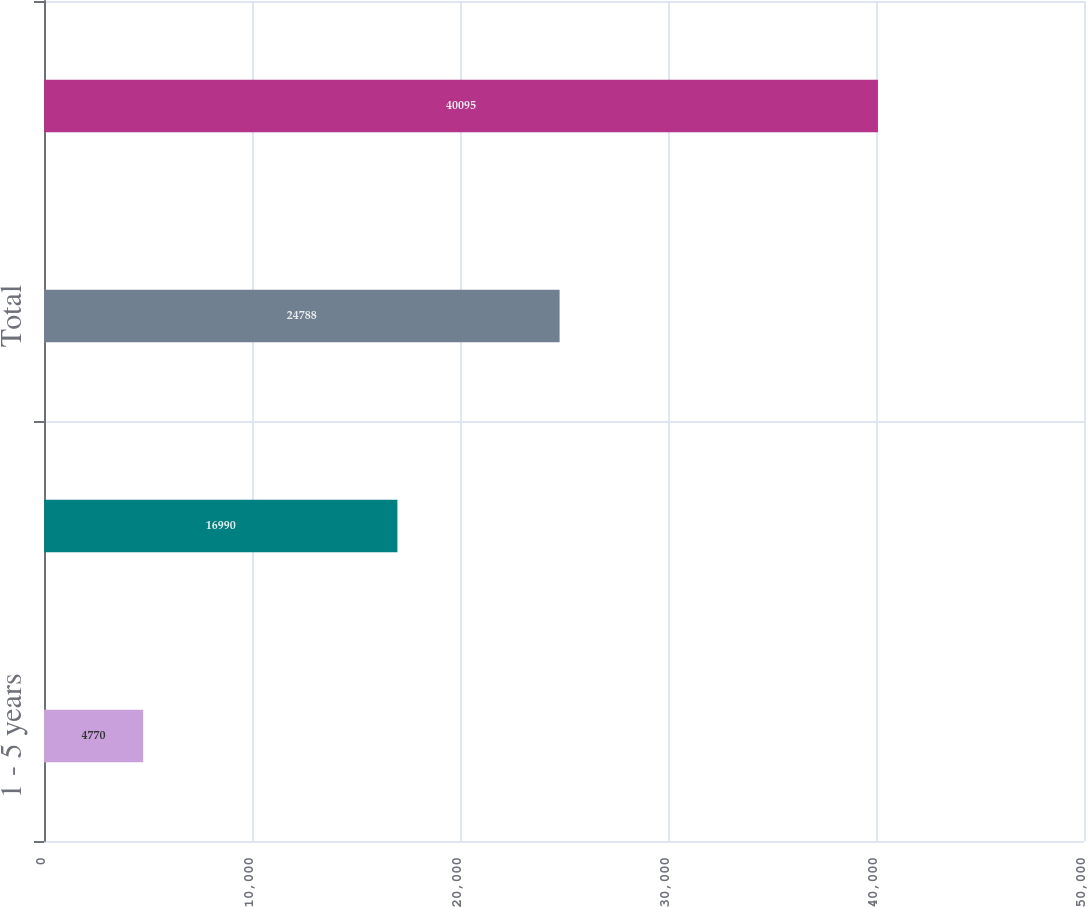<chart> <loc_0><loc_0><loc_500><loc_500><bar_chart><fcel>1 - 5 years<fcel>Greater than 5 years<fcel>Total<fcel>Netting<nl><fcel>4770<fcel>16990<fcel>24788<fcel>40095<nl></chart> 